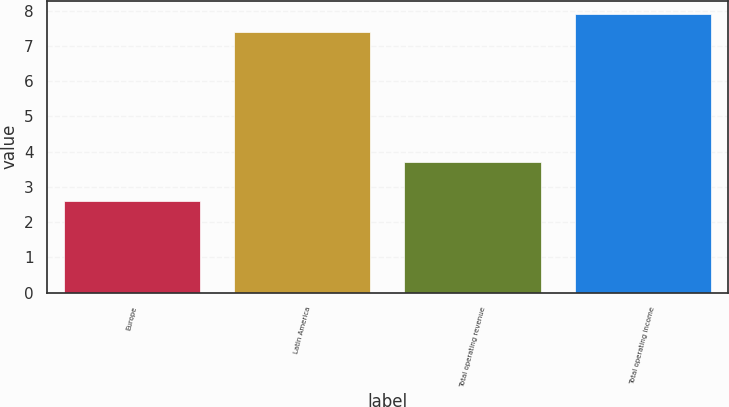Convert chart to OTSL. <chart><loc_0><loc_0><loc_500><loc_500><bar_chart><fcel>Europe<fcel>Latin America<fcel>Total operating revenue<fcel>Total operating income<nl><fcel>2.6<fcel>7.4<fcel>3.7<fcel>7.89<nl></chart> 